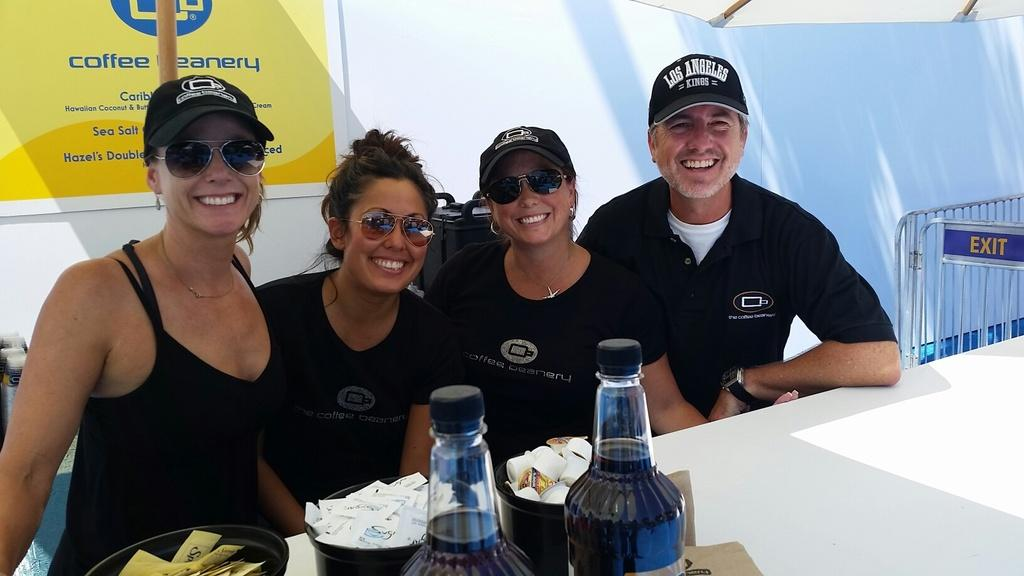How many people are sitting in the image? There are four persons sitting in the image. What are the three persons wearing? Three of the persons are wearing caps. What can be seen on the table in the image? There is a bottle, a bowl, and a paper on the table. What is present in the background of the image? There is a banner in the background of the image. What type of cherries are being digested by the town in the image? There is no mention of cherries or a town in the image. The image features four persons sitting, three of whom are wearing caps, and a table with a bottle, a bowl, and a paper on it, along with a banner in the background. 